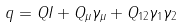Convert formula to latex. <formula><loc_0><loc_0><loc_500><loc_500>q = Q I + Q _ { \mu } \gamma _ { \mu } + Q _ { 1 2 } \gamma _ { 1 } \gamma _ { 2 }</formula> 